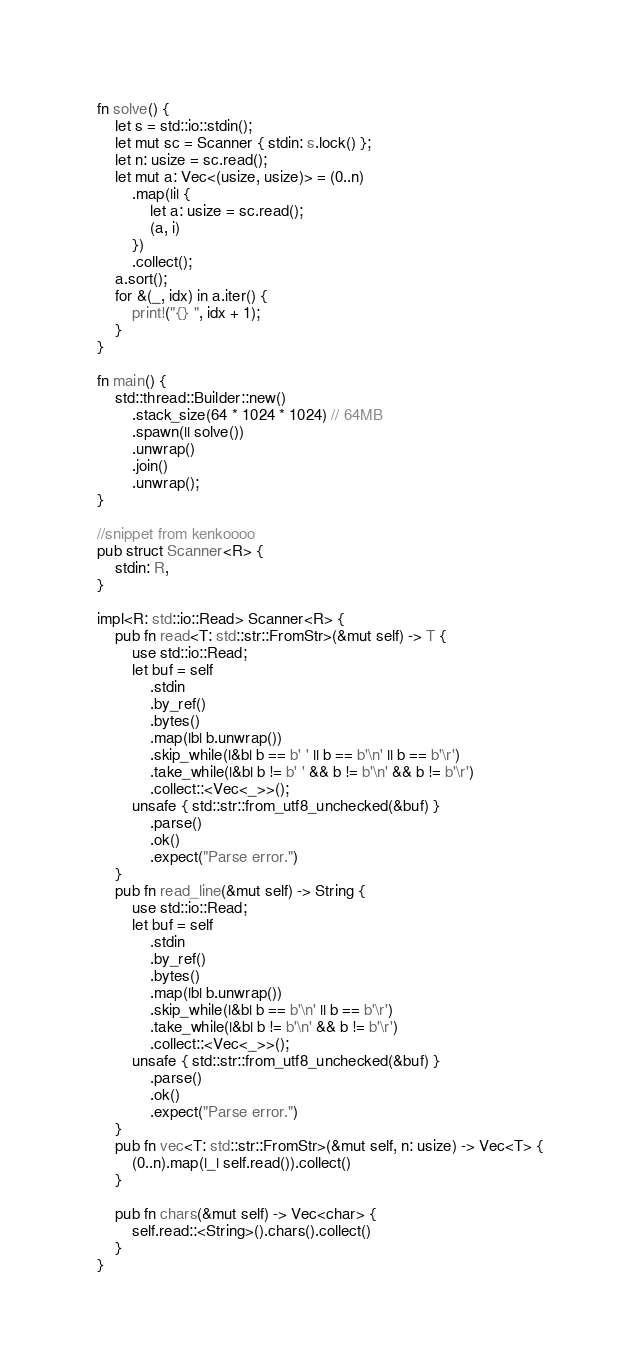<code> <loc_0><loc_0><loc_500><loc_500><_Rust_>fn solve() {
    let s = std::io::stdin();
    let mut sc = Scanner { stdin: s.lock() };
    let n: usize = sc.read();
    let mut a: Vec<(usize, usize)> = (0..n)
        .map(|i| {
            let a: usize = sc.read();
            (a, i)
        })
        .collect();
    a.sort();
    for &(_, idx) in a.iter() {
        print!("{} ", idx + 1);
    }
}

fn main() {
    std::thread::Builder::new()
        .stack_size(64 * 1024 * 1024) // 64MB
        .spawn(|| solve())
        .unwrap()
        .join()
        .unwrap();
}

//snippet from kenkoooo
pub struct Scanner<R> {
    stdin: R,
}

impl<R: std::io::Read> Scanner<R> {
    pub fn read<T: std::str::FromStr>(&mut self) -> T {
        use std::io::Read;
        let buf = self
            .stdin
            .by_ref()
            .bytes()
            .map(|b| b.unwrap())
            .skip_while(|&b| b == b' ' || b == b'\n' || b == b'\r')
            .take_while(|&b| b != b' ' && b != b'\n' && b != b'\r')
            .collect::<Vec<_>>();
        unsafe { std::str::from_utf8_unchecked(&buf) }
            .parse()
            .ok()
            .expect("Parse error.")
    }
    pub fn read_line(&mut self) -> String {
        use std::io::Read;
        let buf = self
            .stdin
            .by_ref()
            .bytes()
            .map(|b| b.unwrap())
            .skip_while(|&b| b == b'\n' || b == b'\r')
            .take_while(|&b| b != b'\n' && b != b'\r')
            .collect::<Vec<_>>();
        unsafe { std::str::from_utf8_unchecked(&buf) }
            .parse()
            .ok()
            .expect("Parse error.")
    }
    pub fn vec<T: std::str::FromStr>(&mut self, n: usize) -> Vec<T> {
        (0..n).map(|_| self.read()).collect()
    }

    pub fn chars(&mut self) -> Vec<char> {
        self.read::<String>().chars().collect()
    }
}
</code> 